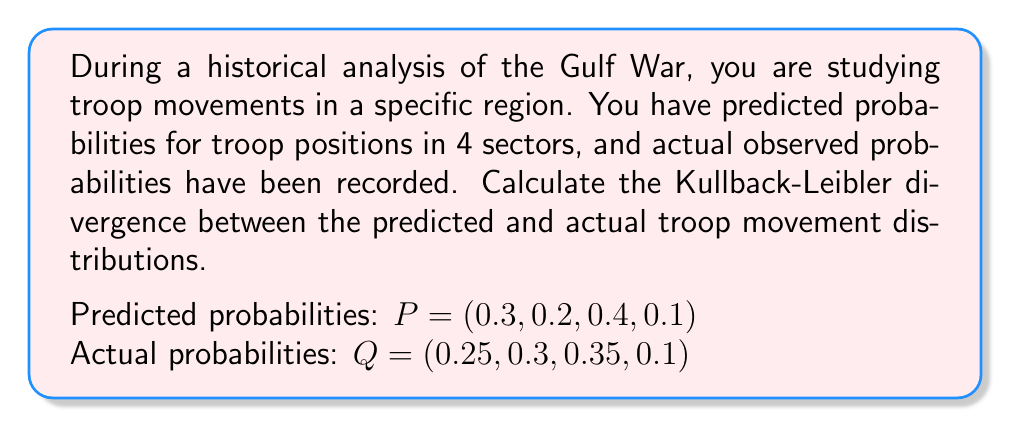Provide a solution to this math problem. To calculate the Kullback-Leibler (KL) divergence between the predicted distribution $P$ and the actual distribution $Q$, we use the formula:

$$ D_{KL}(P||Q) = \sum_{i} P(i) \log \left(\frac{P(i)}{Q(i)}\right) $$

Let's calculate this step-by-step:

1) For $i = 1$:
   $P(1) \log \left(\frac{P(1)}{Q(1)}\right) = 0.3 \log \left(\frac{0.3}{0.25}\right) = 0.3 \times 0.1823 = 0.05469$

2) For $i = 2$:
   $P(2) \log \left(\frac{P(2)}{Q(2)}\right) = 0.2 \log \left(\frac{0.2}{0.3}\right) = 0.2 \times (-0.4055) = -0.0811$

3) For $i = 3$:
   $P(3) \log \left(\frac{P(3)}{Q(3)}\right) = 0.4 \log \left(\frac{0.4}{0.35}\right) = 0.4 \times 0.1335 = 0.0534$

4) For $i = 4$:
   $P(4) \log \left(\frac{P(4)}{Q(4)}\right) = 0.1 \log \left(\frac{0.1}{0.1}\right) = 0.1 \times 0 = 0$

5) Sum all these values:
   $D_{KL}(P||Q) = 0.05469 + (-0.0811) + 0.0534 + 0 = 0.02699$

The KL divergence is approximately 0.02699 nats (if using natural logarithm) or 0.03894 bits (if using log base 2).
Answer: The Kullback-Leibler divergence between the predicted and actual troop movement distributions is approximately 0.02699 nats. 